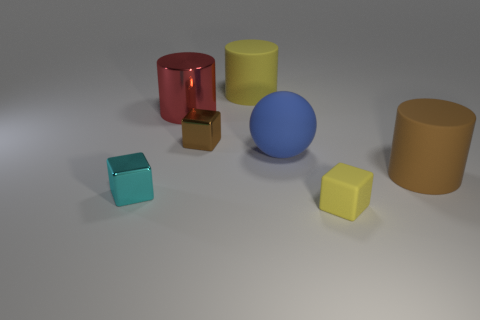Add 1 small purple metallic cubes. How many objects exist? 8 Subtract all cylinders. How many objects are left? 4 Subtract all tiny brown metal blocks. Subtract all large brown things. How many objects are left? 5 Add 5 brown rubber things. How many brown rubber things are left? 6 Add 1 tiny red metal blocks. How many tiny red metal blocks exist? 1 Subtract 1 brown cubes. How many objects are left? 6 